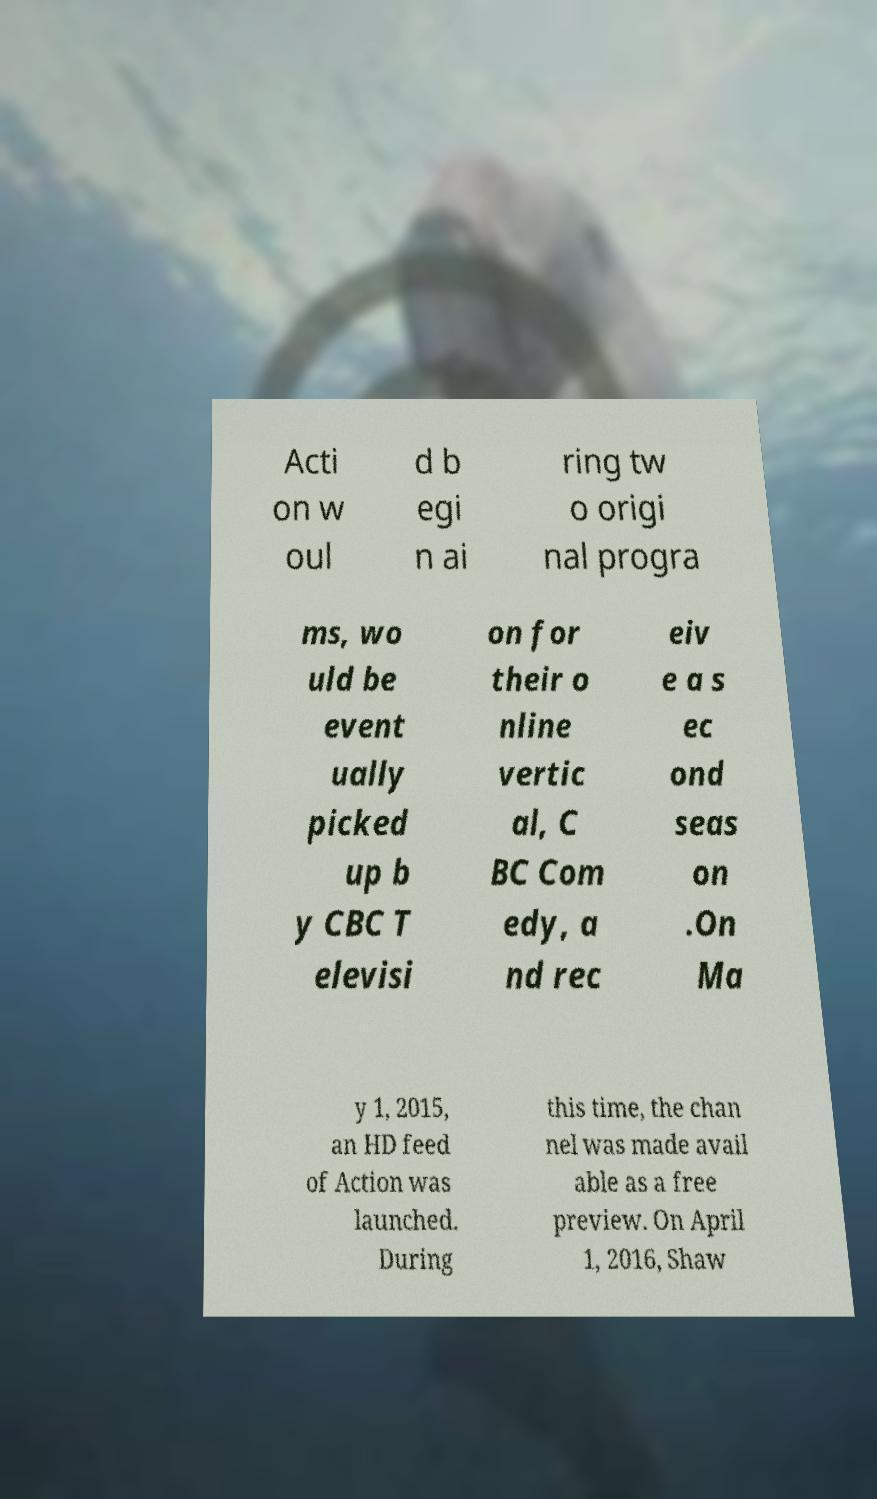For documentation purposes, I need the text within this image transcribed. Could you provide that? Acti on w oul d b egi n ai ring tw o origi nal progra ms, wo uld be event ually picked up b y CBC T elevisi on for their o nline vertic al, C BC Com edy, a nd rec eiv e a s ec ond seas on .On Ma y 1, 2015, an HD feed of Action was launched. During this time, the chan nel was made avail able as a free preview. On April 1, 2016, Shaw 